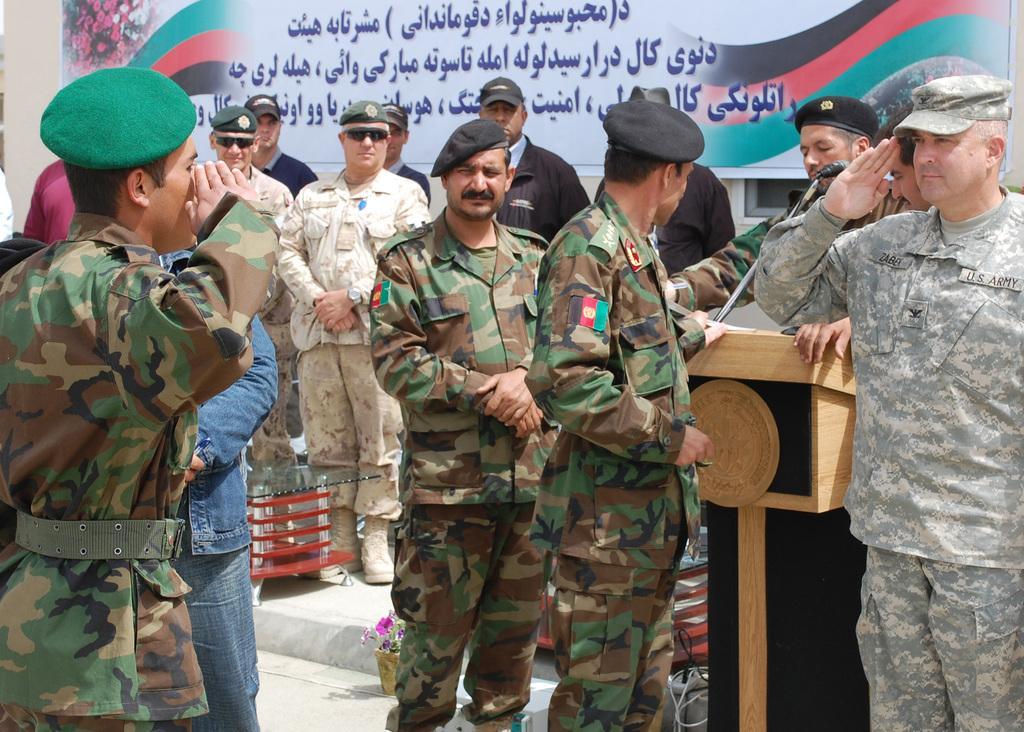How would you summarize this image in a sentence or two? In this picture we can see group of persons who are wearing army uniform. On the right there is a man who is standing near to the speech desk and mic. On the background we can see a banner. On the bottom there is a plant in a pot. Here we can see glass table. There is a man who is wearing cap, goggles, shirt, trouser and shoe. 